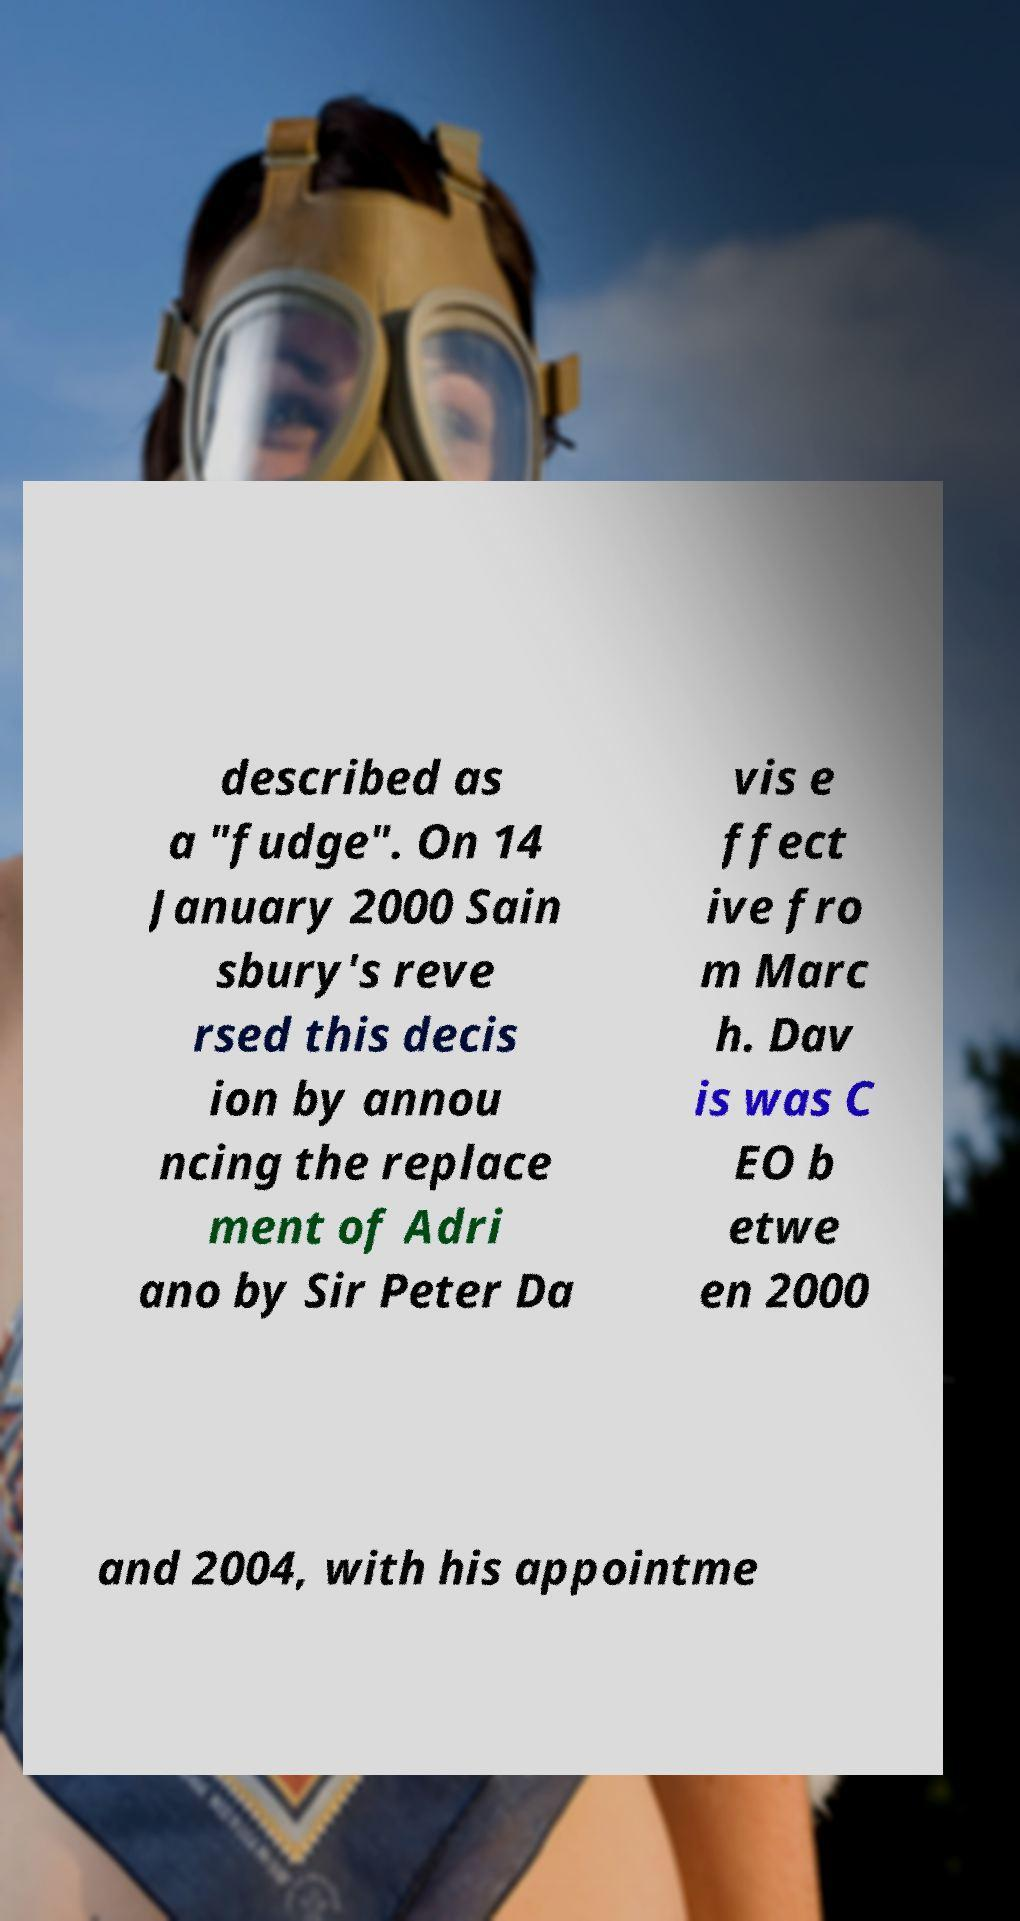For documentation purposes, I need the text within this image transcribed. Could you provide that? described as a "fudge". On 14 January 2000 Sain sbury's reve rsed this decis ion by annou ncing the replace ment of Adri ano by Sir Peter Da vis e ffect ive fro m Marc h. Dav is was C EO b etwe en 2000 and 2004, with his appointme 